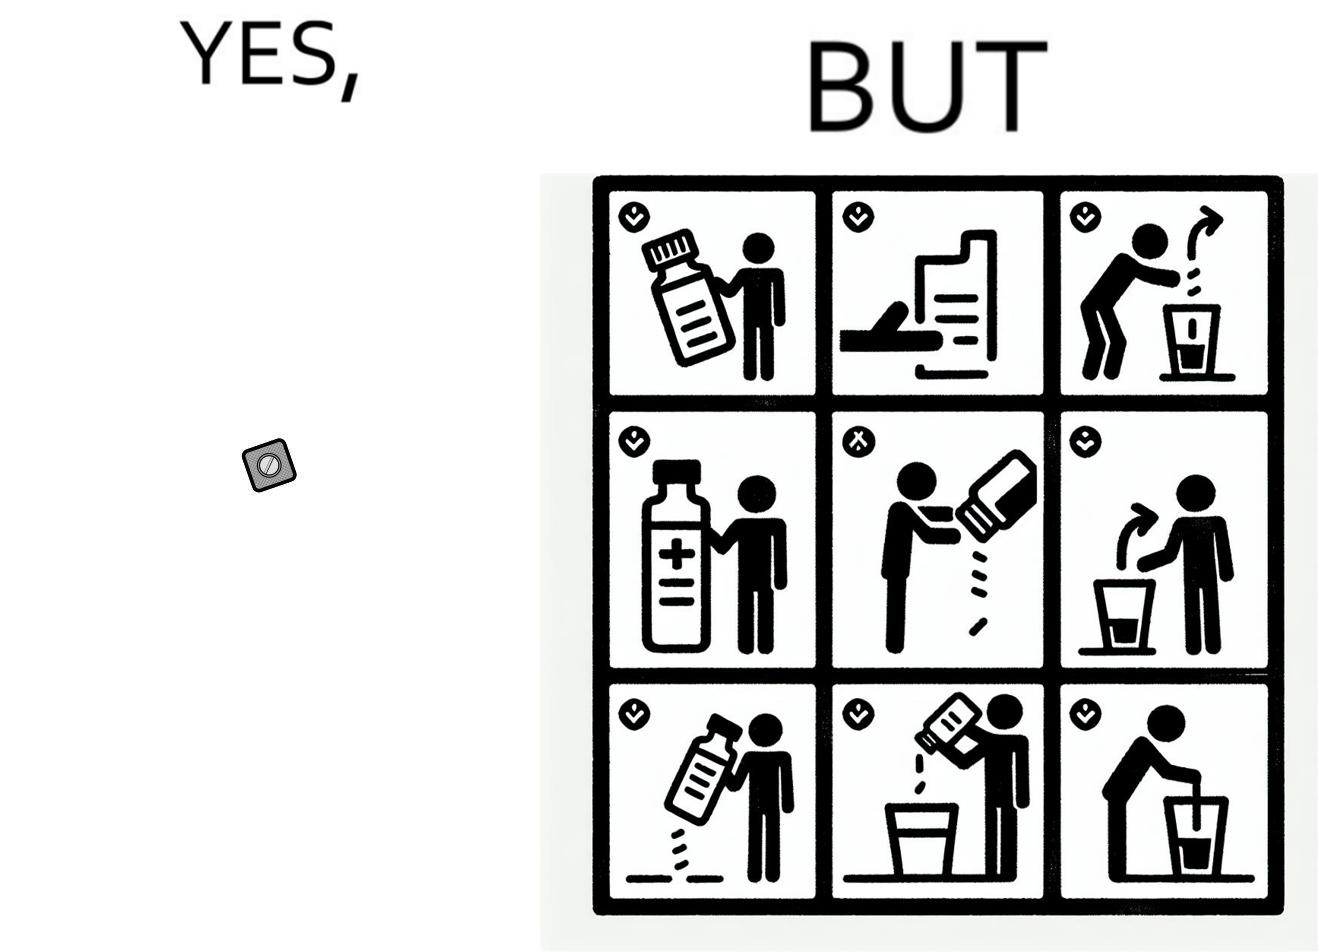Describe what you see in this image. the irony in this image is a small thing like a medicine very often has instructions and a manual that is extremely long 